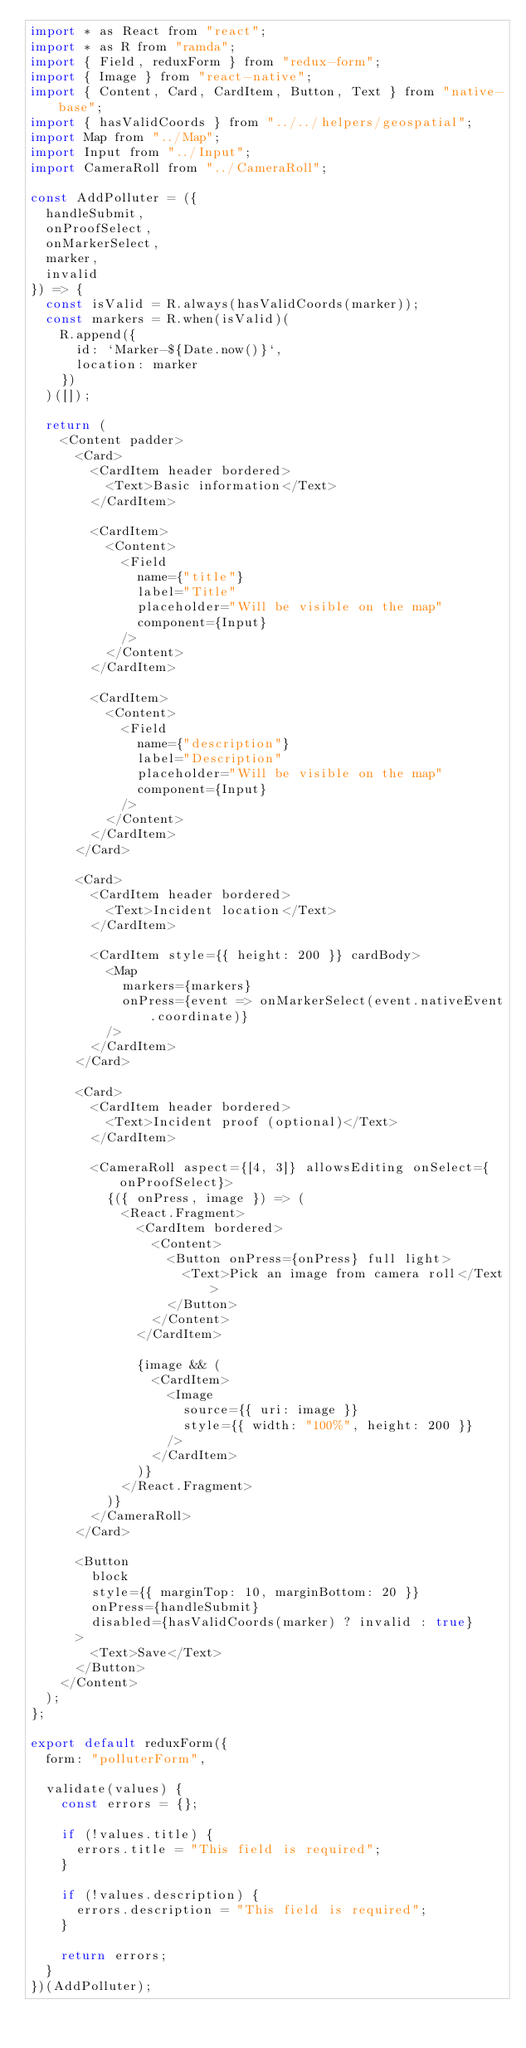Convert code to text. <code><loc_0><loc_0><loc_500><loc_500><_JavaScript_>import * as React from "react";
import * as R from "ramda";
import { Field, reduxForm } from "redux-form";
import { Image } from "react-native";
import { Content, Card, CardItem, Button, Text } from "native-base";
import { hasValidCoords } from "../../helpers/geospatial";
import Map from "../Map";
import Input from "../Input";
import CameraRoll from "../CameraRoll";

const AddPolluter = ({
  handleSubmit,
  onProofSelect,
  onMarkerSelect,
  marker,
  invalid
}) => {
  const isValid = R.always(hasValidCoords(marker));
  const markers = R.when(isValid)(
    R.append({
      id: `Marker-${Date.now()}`,
      location: marker
    })
  )([]);

  return (
    <Content padder>
      <Card>
        <CardItem header bordered>
          <Text>Basic information</Text>
        </CardItem>

        <CardItem>
          <Content>
            <Field
              name={"title"}
              label="Title"
              placeholder="Will be visible on the map"
              component={Input}
            />
          </Content>
        </CardItem>

        <CardItem>
          <Content>
            <Field
              name={"description"}
              label="Description"
              placeholder="Will be visible on the map"
              component={Input}
            />
          </Content>
        </CardItem>
      </Card>

      <Card>
        <CardItem header bordered>
          <Text>Incident location</Text>
        </CardItem>

        <CardItem style={{ height: 200 }} cardBody>
          <Map
            markers={markers}
            onPress={event => onMarkerSelect(event.nativeEvent.coordinate)}
          />
        </CardItem>
      </Card>

      <Card>
        <CardItem header bordered>
          <Text>Incident proof (optional)</Text>
        </CardItem>

        <CameraRoll aspect={[4, 3]} allowsEditing onSelect={onProofSelect}>
          {({ onPress, image }) => (
            <React.Fragment>
              <CardItem bordered>
                <Content>
                  <Button onPress={onPress} full light>
                    <Text>Pick an image from camera roll</Text>
                  </Button>
                </Content>
              </CardItem>

              {image && (
                <CardItem>
                  <Image
                    source={{ uri: image }}
                    style={{ width: "100%", height: 200 }}
                  />
                </CardItem>
              )}
            </React.Fragment>
          )}
        </CameraRoll>
      </Card>

      <Button
        block
        style={{ marginTop: 10, marginBottom: 20 }}
        onPress={handleSubmit}
        disabled={hasValidCoords(marker) ? invalid : true}
      >
        <Text>Save</Text>
      </Button>
    </Content>
  );
};

export default reduxForm({
  form: "polluterForm",

  validate(values) {
    const errors = {};

    if (!values.title) {
      errors.title = "This field is required";
    }

    if (!values.description) {
      errors.description = "This field is required";
    }

    return errors;
  }
})(AddPolluter);
</code> 